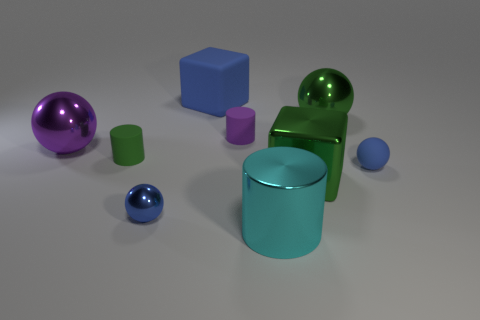Subtract all rubber cylinders. How many cylinders are left? 1 Add 1 large cyan metallic cylinders. How many objects exist? 10 Subtract all purple balls. How many balls are left? 3 Add 1 big cyan cylinders. How many big cyan cylinders exist? 2 Subtract 0 red cylinders. How many objects are left? 9 Subtract all cylinders. How many objects are left? 6 Subtract 2 blocks. How many blocks are left? 0 Subtract all gray balls. Subtract all cyan cylinders. How many balls are left? 4 Subtract all brown balls. How many blue blocks are left? 1 Subtract all small spheres. Subtract all large objects. How many objects are left? 2 